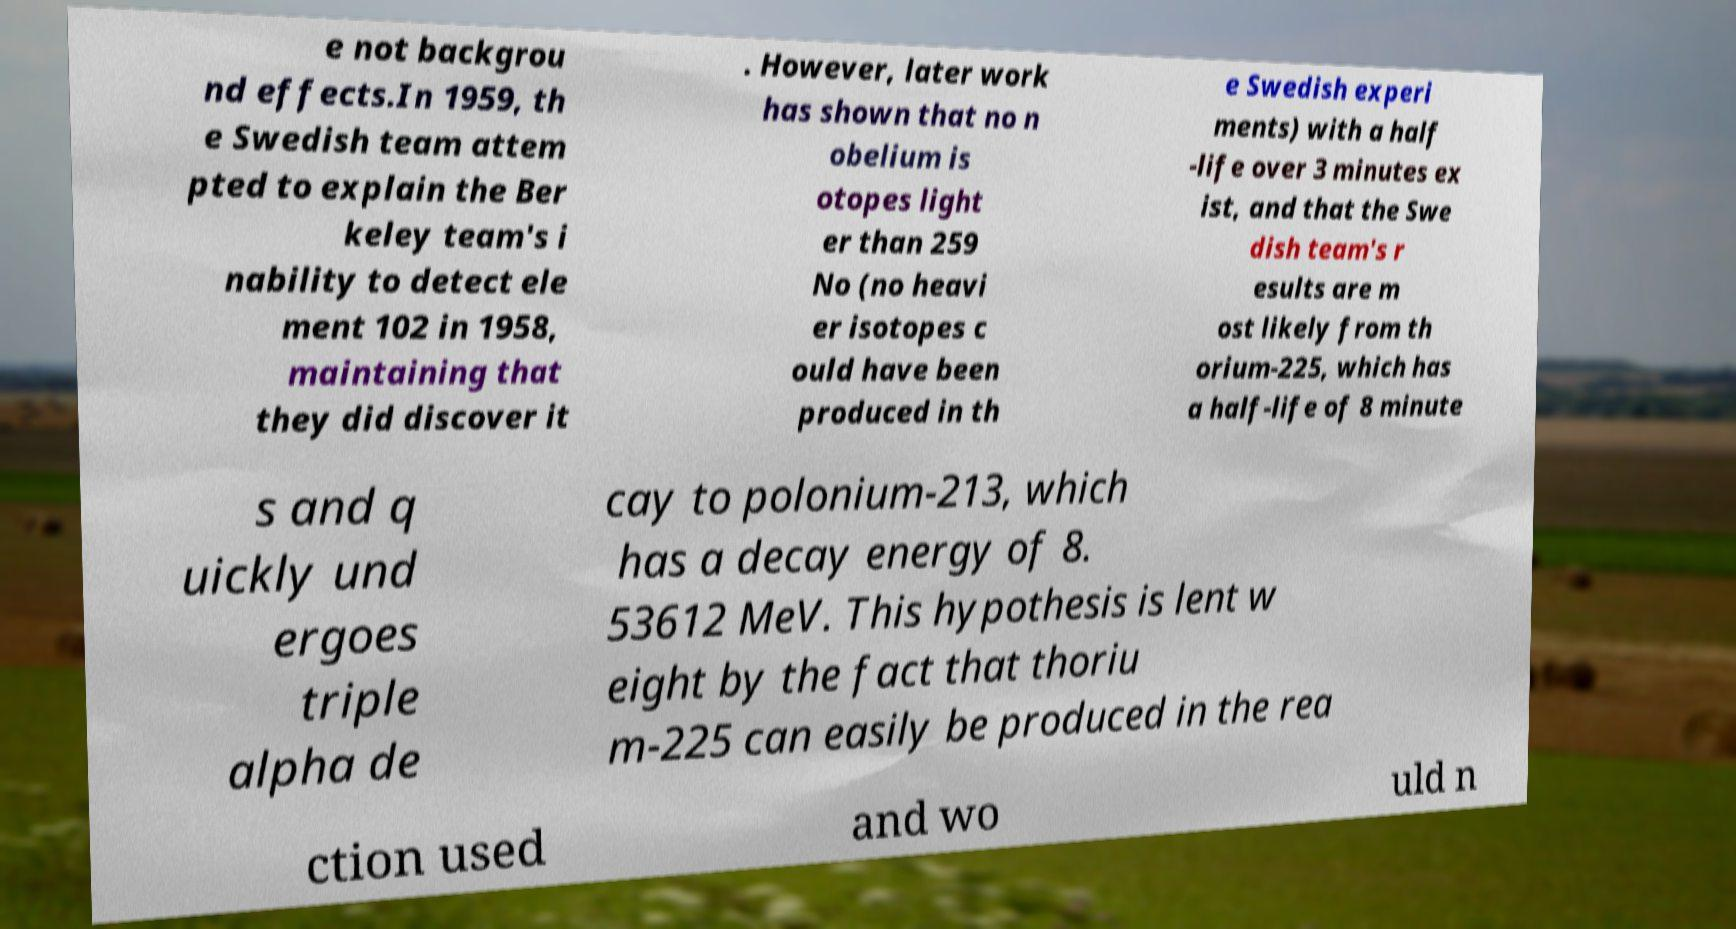Can you accurately transcribe the text from the provided image for me? e not backgrou nd effects.In 1959, th e Swedish team attem pted to explain the Ber keley team's i nability to detect ele ment 102 in 1958, maintaining that they did discover it . However, later work has shown that no n obelium is otopes light er than 259 No (no heavi er isotopes c ould have been produced in th e Swedish experi ments) with a half -life over 3 minutes ex ist, and that the Swe dish team's r esults are m ost likely from th orium-225, which has a half-life of 8 minute s and q uickly und ergoes triple alpha de cay to polonium-213, which has a decay energy of 8. 53612 MeV. This hypothesis is lent w eight by the fact that thoriu m-225 can easily be produced in the rea ction used and wo uld n 